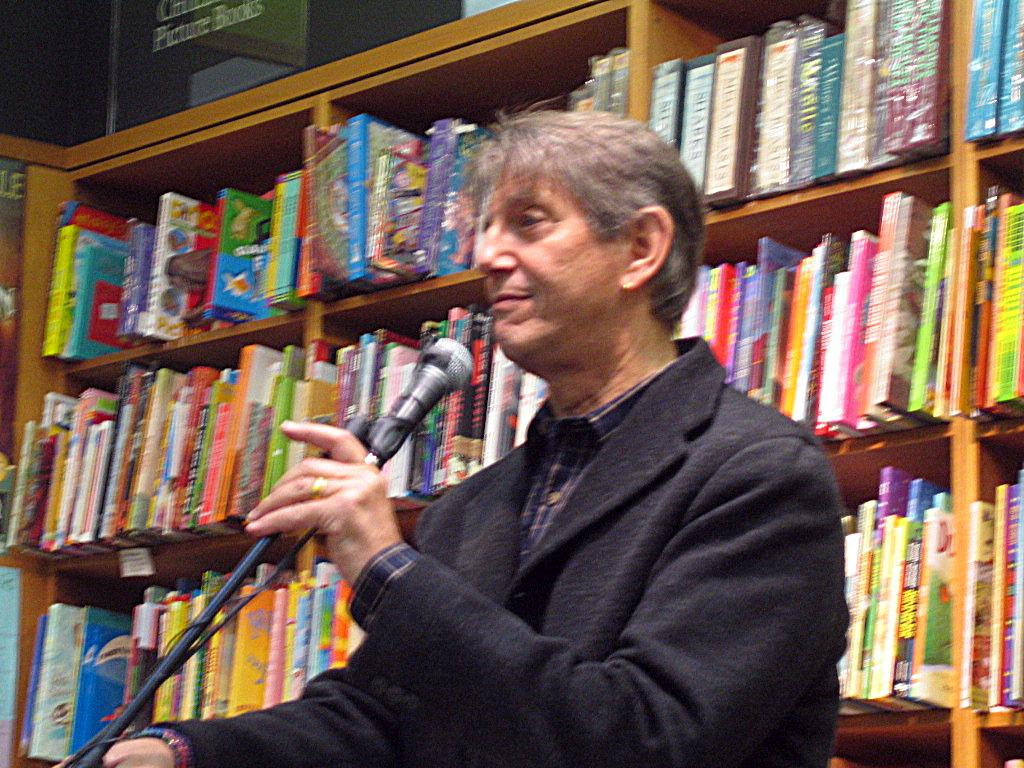What is the man in the image holding? The man is holding microphones. What can be seen in the background of the image? There are books in the background of the image. How are the books arranged in the image? The books are in racks. What type of cough medicine is the man taking in the image? There is no indication in the image that the man is taking any cough medicine. What type of cord is visible in the image? There is no cord visible in the image. 